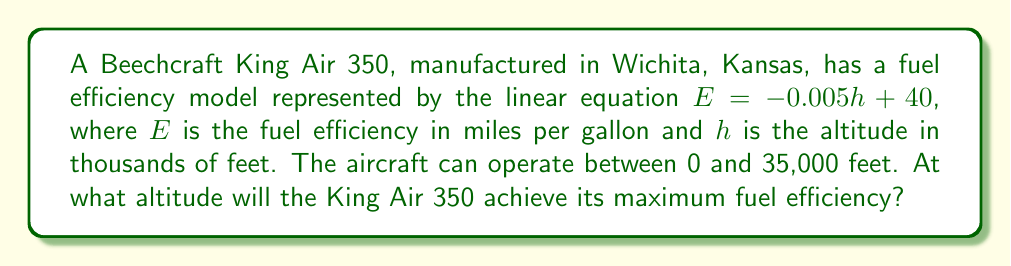Help me with this question. To find the optimal altitude for maximum fuel efficiency, we need to analyze the given linear equation:

1. The equation is $E = -0.005h + 40$, where:
   $E$ = fuel efficiency in miles per gallon
   $h$ = altitude in thousands of feet

2. This is a linear equation with a negative slope (-0.005). This means that as altitude increases, fuel efficiency decreases.

3. The y-intercept is 40, which represents the fuel efficiency at sea level (0 feet altitude).

4. Since the relationship is linear and has a negative slope, the maximum fuel efficiency will occur at the lowest possible altitude.

5. The question states that the aircraft can operate between 0 and 35,000 feet.

6. Therefore, the optimal altitude for maximum fuel efficiency is at sea level, or 0 feet.

7. We can verify this by calculating the fuel efficiency at both extremes:
   At 0 feet: $E = -0.005(0) + 40 = 40$ mpg
   At 35,000 feet: $E = -0.005(35) + 40 = 39.825$ mpg

8. This confirms that the fuel efficiency is highest at the lowest altitude (0 feet).
Answer: 0 feet 